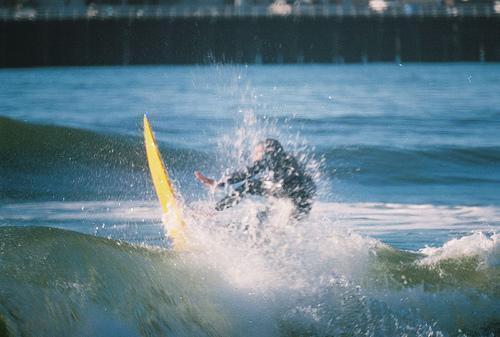How many people do you see?
Give a very brief answer. 1. 